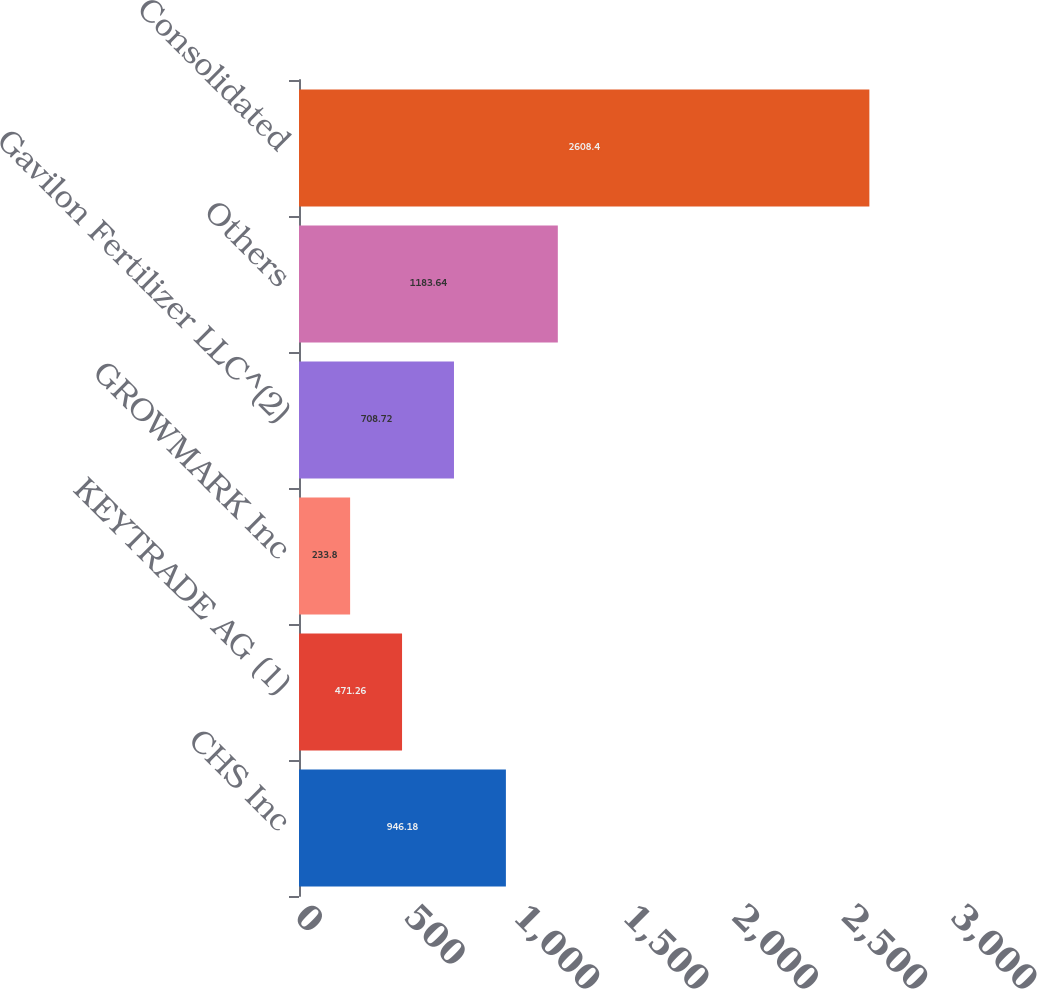Convert chart. <chart><loc_0><loc_0><loc_500><loc_500><bar_chart><fcel>CHS Inc<fcel>KEYTRADE AG (1)<fcel>GROWMARK Inc<fcel>Gavilon Fertilizer LLC^(2)<fcel>Others<fcel>Consolidated<nl><fcel>946.18<fcel>471.26<fcel>233.8<fcel>708.72<fcel>1183.64<fcel>2608.4<nl></chart> 